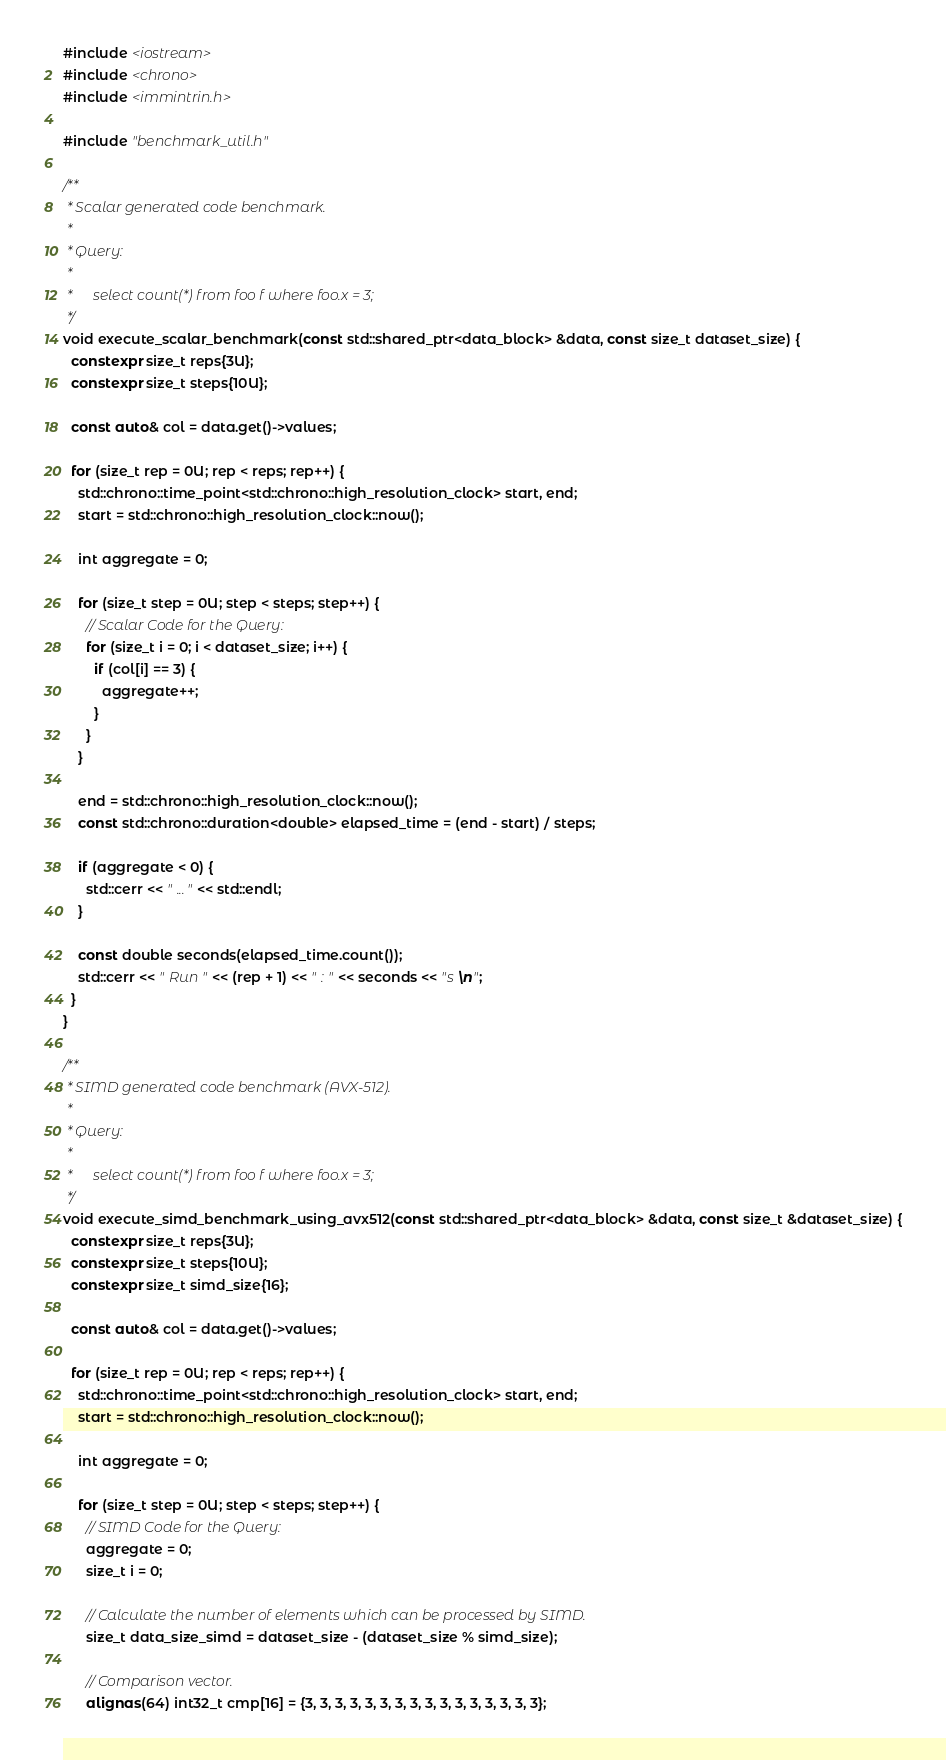<code> <loc_0><loc_0><loc_500><loc_500><_C++_>#include <iostream>
#include <chrono>
#include <immintrin.h>

#include "benchmark_util.h"

/**
 * Scalar generated code benchmark.
 *
 * Query:
 *
 *      select count(*) from foo f where foo.x = 3;
 */
void execute_scalar_benchmark(const std::shared_ptr<data_block> &data, const size_t dataset_size) {
  constexpr size_t reps{3U};
  constexpr size_t steps{10U};

  const auto& col = data.get()->values;

  for (size_t rep = 0U; rep < reps; rep++) {
    std::chrono::time_point<std::chrono::high_resolution_clock> start, end;
    start = std::chrono::high_resolution_clock::now();

    int aggregate = 0;

    for (size_t step = 0U; step < steps; step++) {
      // Scalar Code for the Query:
      for (size_t i = 0; i < dataset_size; i++) {
        if (col[i] == 3) {
          aggregate++;
        }
      }
    }

    end = std::chrono::high_resolution_clock::now();
    const std::chrono::duration<double> elapsed_time = (end - start) / steps;

    if (aggregate < 0) {
      std::cerr << " ..." << std::endl;
    }

    const double seconds(elapsed_time.count());
    std::cerr << " Run " << (rep + 1) << " : " << seconds << "s \n";
  }
}

/**
 * SIMD generated code benchmark (AVX-512).
 *
 * Query:
 *
 *      select count(*) from foo f where foo.x = 3;
 */
void execute_simd_benchmark_using_avx512(const std::shared_ptr<data_block> &data, const size_t &dataset_size) {
  constexpr size_t reps{3U};
  constexpr size_t steps{10U};
  constexpr size_t simd_size{16};

  const auto& col = data.get()->values;

  for (size_t rep = 0U; rep < reps; rep++) {
    std::chrono::time_point<std::chrono::high_resolution_clock> start, end;
    start = std::chrono::high_resolution_clock::now();

    int aggregate = 0;

    for (size_t step = 0U; step < steps; step++) {
      // SIMD Code for the Query:
      aggregate = 0;
      size_t i = 0;

      // Calculate the number of elements which can be processed by SIMD.
      size_t data_size_simd = dataset_size - (dataset_size % simd_size);

      // Comparison vector.
      alignas(64) int32_t cmp[16] = {3, 3, 3, 3, 3, 3, 3, 3, 3, 3, 3, 3, 3, 3, 3, 3};</code> 